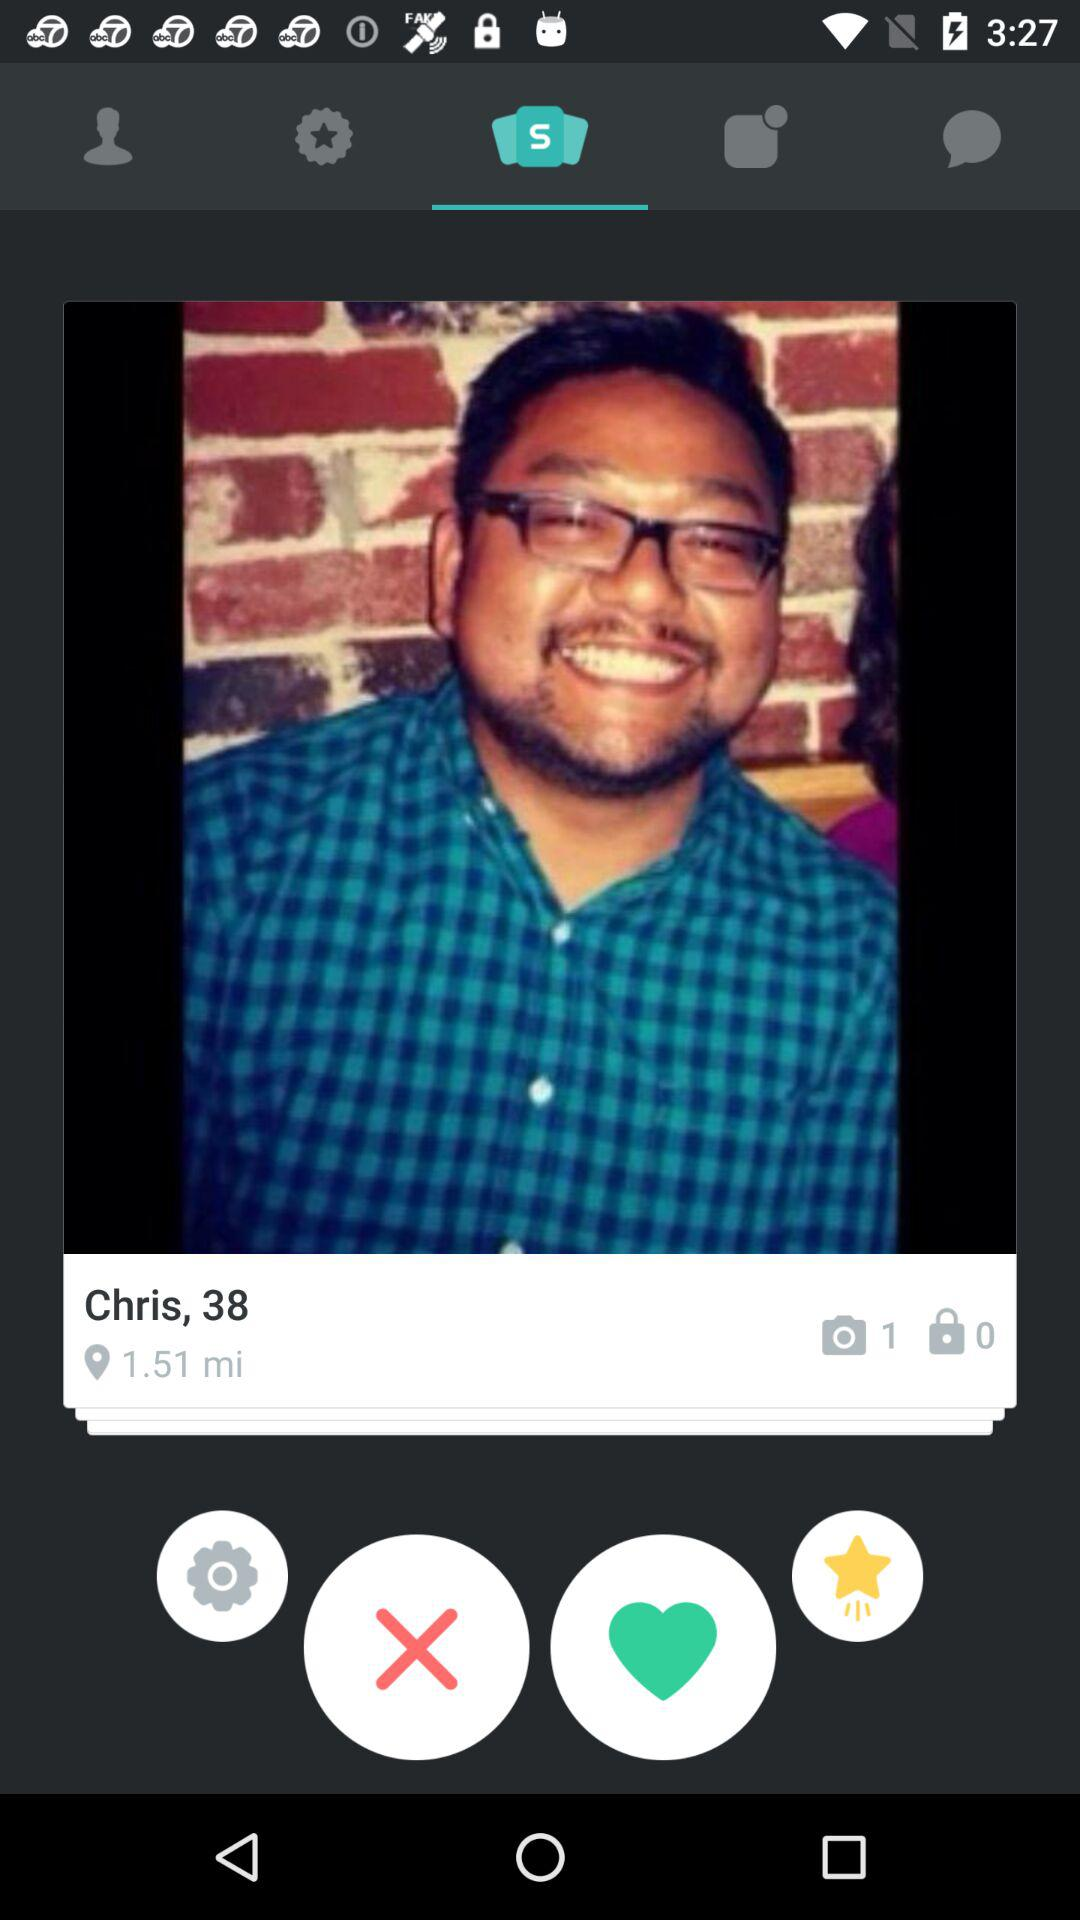What is the name of the user? The name of the user is Chris. 